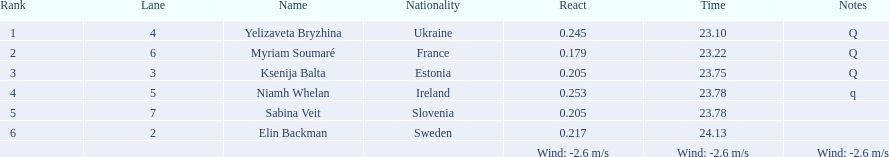Who is the first ranking player? Yelizaveta Bryzhina. 